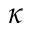Convert formula to latex. <formula><loc_0><loc_0><loc_500><loc_500>\kappa</formula> 